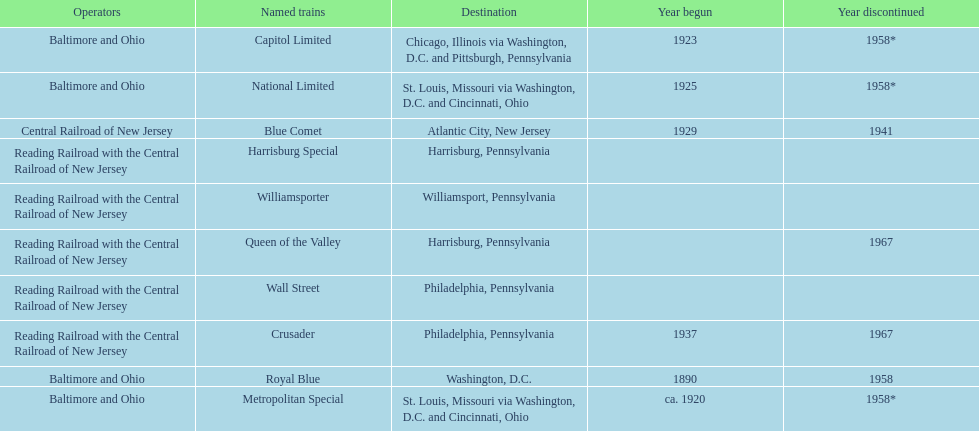What is the total number of year begun? 6. 